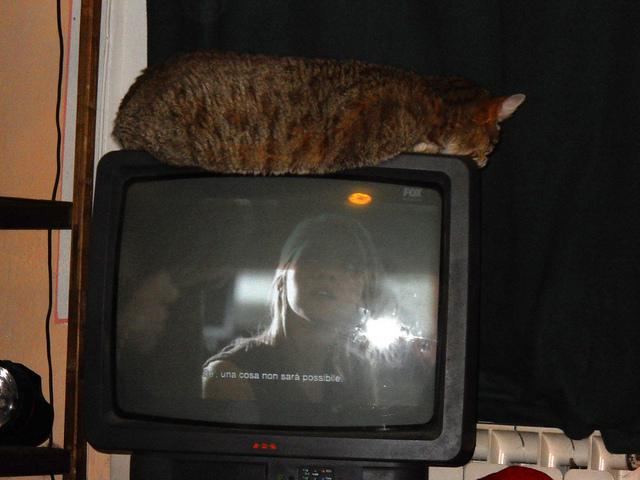Why is the cat sitting here? warmth 